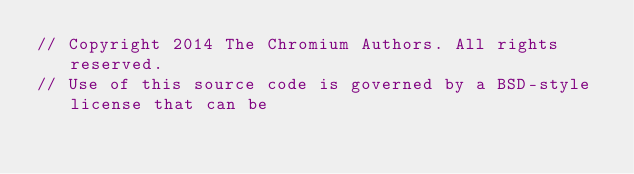<code> <loc_0><loc_0><loc_500><loc_500><_ObjectiveC_>// Copyright 2014 The Chromium Authors. All rights reserved.
// Use of this source code is governed by a BSD-style license that can be</code> 